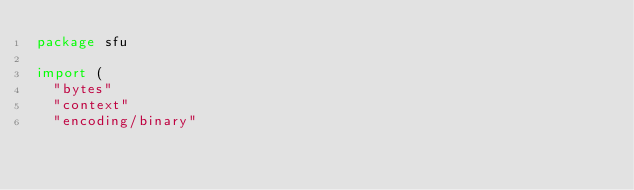Convert code to text. <code><loc_0><loc_0><loc_500><loc_500><_Go_>package sfu

import (
	"bytes"
	"context"
	"encoding/binary"</code> 